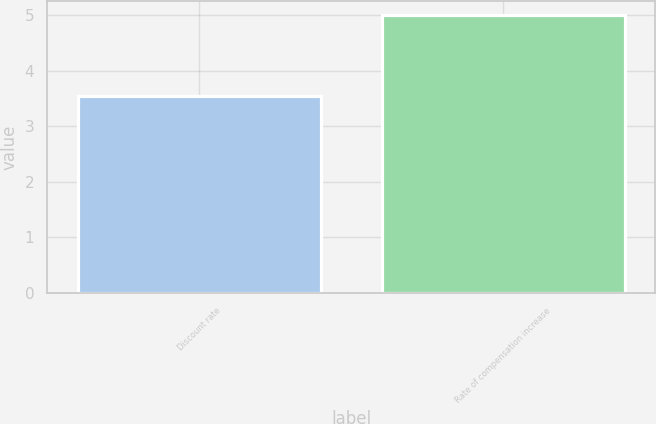Convert chart to OTSL. <chart><loc_0><loc_0><loc_500><loc_500><bar_chart><fcel>Discount rate<fcel>Rate of compensation increase<nl><fcel>3.55<fcel>5<nl></chart> 